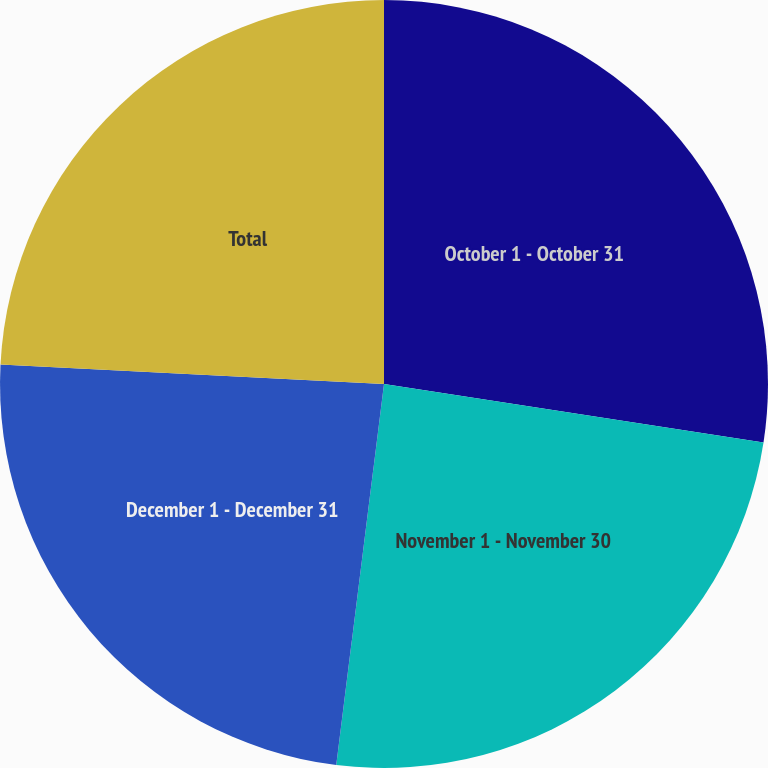Convert chart. <chart><loc_0><loc_0><loc_500><loc_500><pie_chart><fcel>October 1 - October 31<fcel>November 1 - November 30<fcel>December 1 - December 31<fcel>Total<nl><fcel>27.44%<fcel>24.55%<fcel>23.83%<fcel>24.19%<nl></chart> 